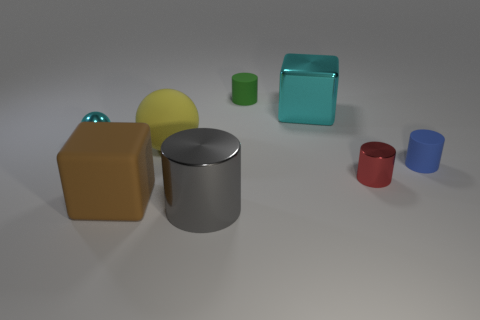Add 1 large cyan metal cylinders. How many objects exist? 9 Subtract all cubes. How many objects are left? 6 Subtract 1 blue cylinders. How many objects are left? 7 Subtract all metal blocks. Subtract all red objects. How many objects are left? 6 Add 2 big rubber blocks. How many big rubber blocks are left? 3 Add 5 large brown matte things. How many large brown matte things exist? 6 